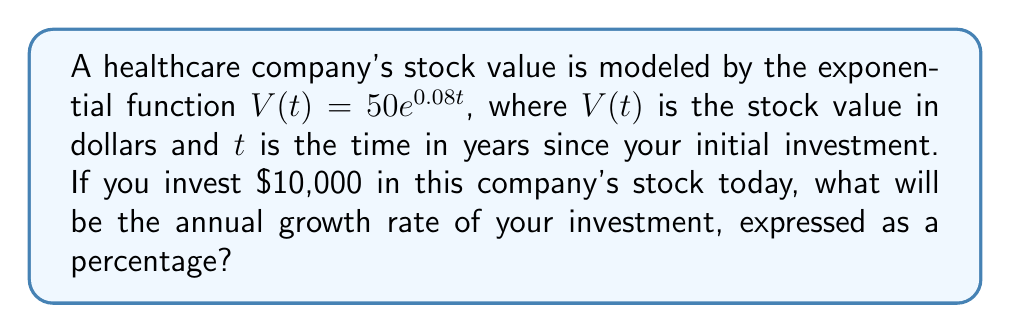Help me with this question. To solve this problem, we'll follow these steps:

1) The exponential function is given as $V(t) = 50e^{0.08t}$

2) In an exponential function of the form $f(t) = ae^{rt}$, $r$ represents the continuous growth rate.

3) In our function, $r = 0.08$

4) However, this is the continuous growth rate. To convert it to an annual percentage growth rate, we need to use the formula:

   Annual Growth Rate = $e^r - 1$

5) Substituting our $r$ value:
   
   Annual Growth Rate = $e^{0.08} - 1$

6) Calculate:
   $e^{0.08} \approx 1.0832870$
   
   $1.0832870 - 1 = 0.0832870$

7) Convert to percentage:
   $0.0832870 \times 100\% = 8.3287\%$

Therefore, the annual growth rate is approximately 8.33%.
Answer: 8.33% 